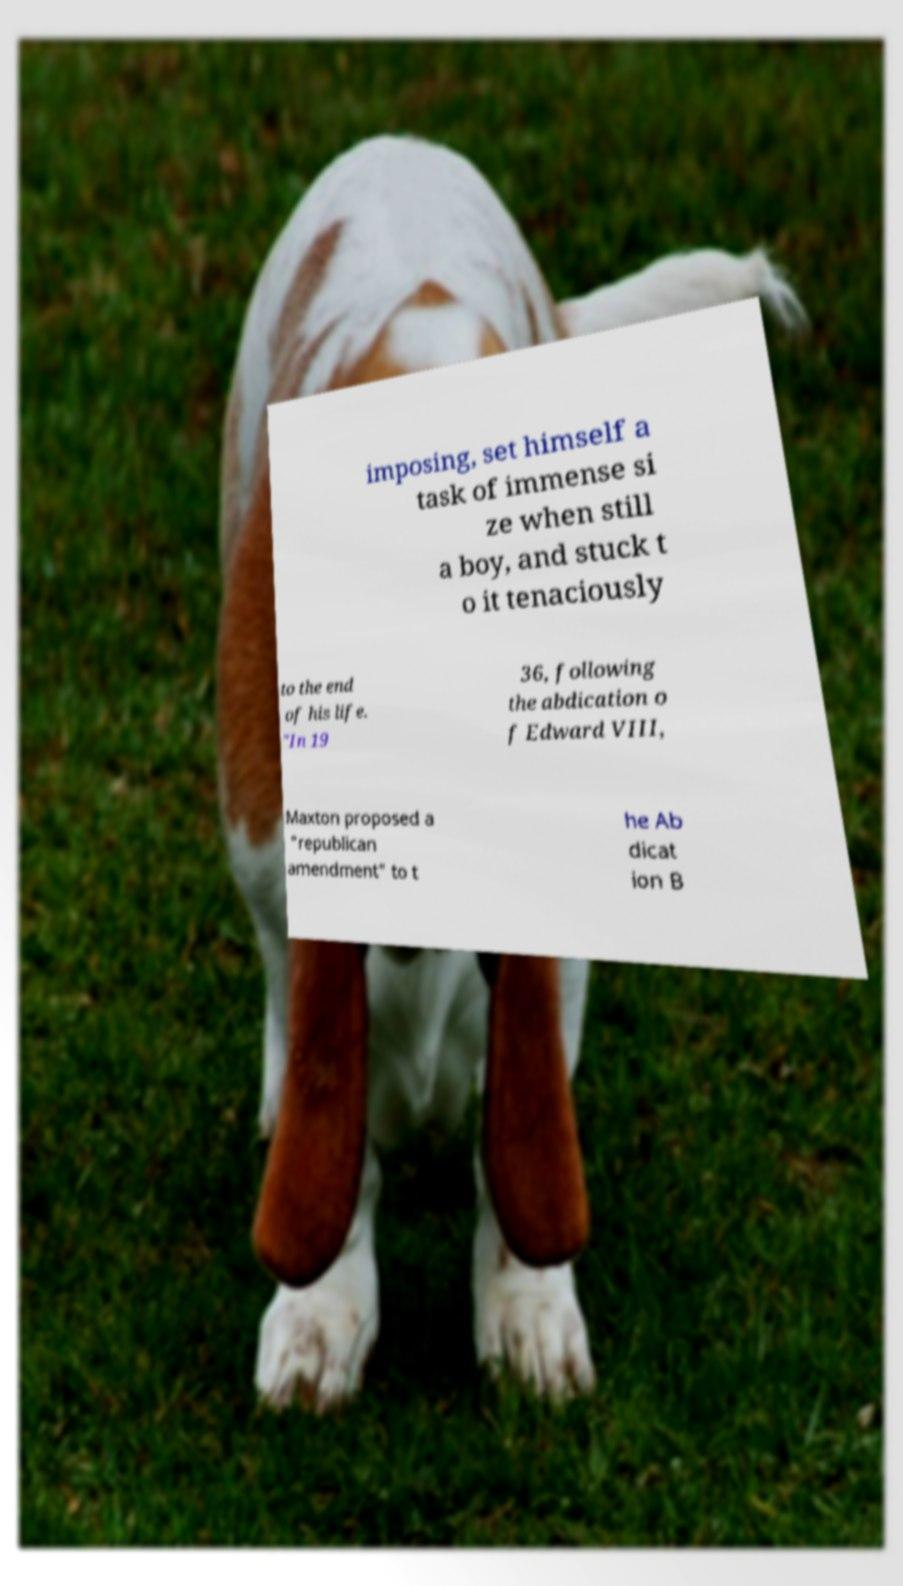I need the written content from this picture converted into text. Can you do that? imposing, set himself a task of immense si ze when still a boy, and stuck t o it tenaciously to the end of his life. "In 19 36, following the abdication o f Edward VIII, Maxton proposed a "republican amendment" to t he Ab dicat ion B 